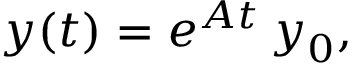<formula> <loc_0><loc_0><loc_500><loc_500>y ( t ) = e ^ { A t } \, y _ { 0 } ,</formula> 